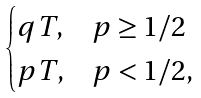Convert formula to latex. <formula><loc_0><loc_0><loc_500><loc_500>\begin{cases} q T , & p \geq 1 / 2 \\ p T , & p < 1 / 2 , \end{cases}</formula> 